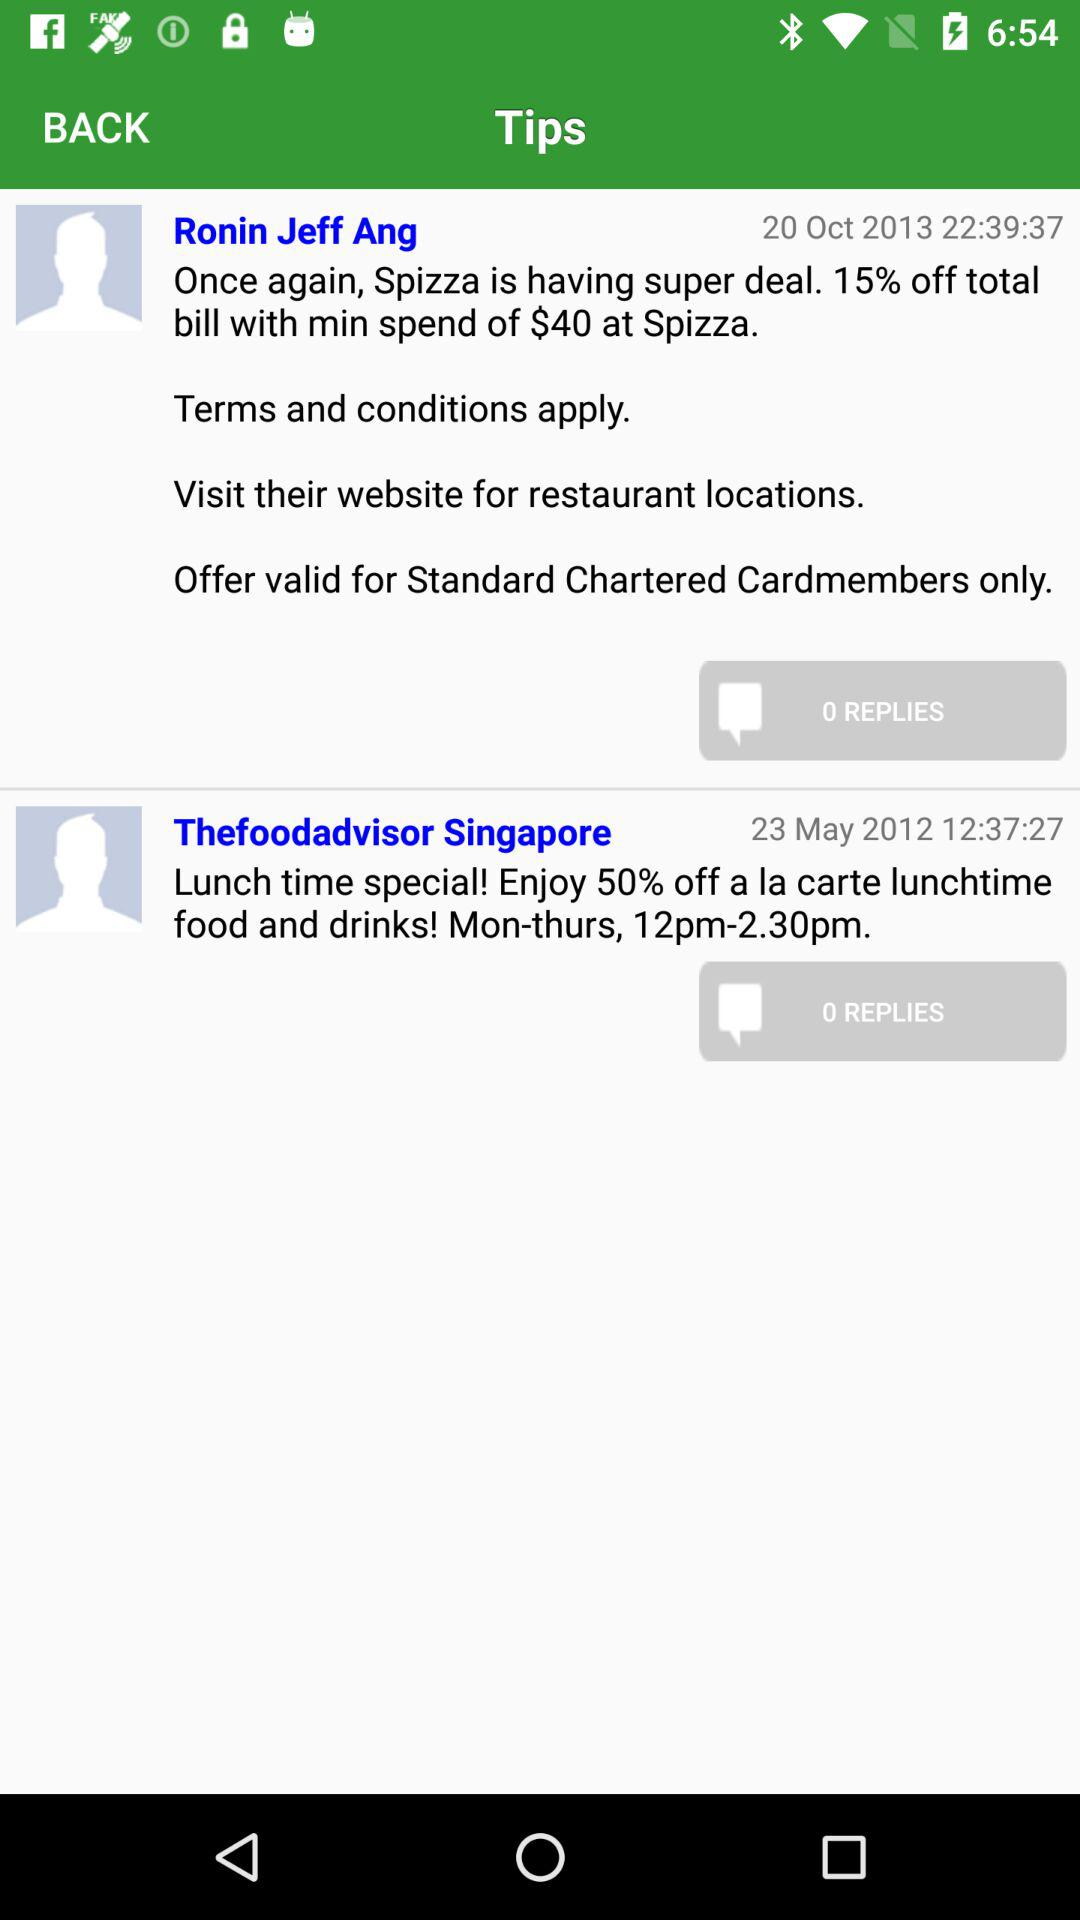How many tips are there?
Answer the question using a single word or phrase. 2 